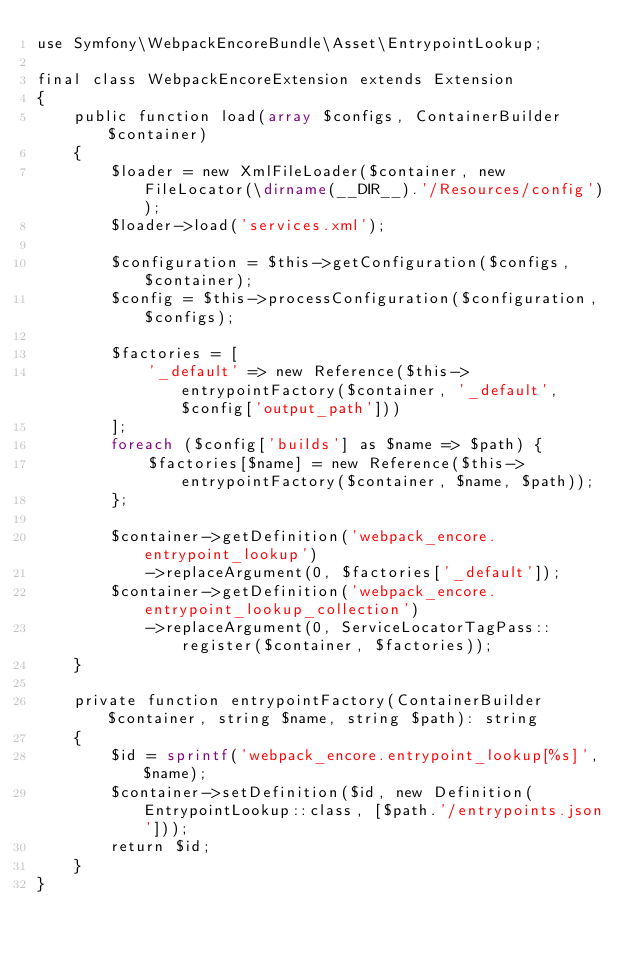<code> <loc_0><loc_0><loc_500><loc_500><_PHP_>use Symfony\WebpackEncoreBundle\Asset\EntrypointLookup;

final class WebpackEncoreExtension extends Extension
{
    public function load(array $configs, ContainerBuilder $container)
    {
        $loader = new XmlFileLoader($container, new FileLocator(\dirname(__DIR__).'/Resources/config'));
        $loader->load('services.xml');

        $configuration = $this->getConfiguration($configs, $container);
        $config = $this->processConfiguration($configuration, $configs);

        $factories = [
            '_default' => new Reference($this->entrypointFactory($container, '_default', $config['output_path']))
        ];
        foreach ($config['builds'] as $name => $path) {
            $factories[$name] = new Reference($this->entrypointFactory($container, $name, $path));
        };

        $container->getDefinition('webpack_encore.entrypoint_lookup')
            ->replaceArgument(0, $factories['_default']);
        $container->getDefinition('webpack_encore.entrypoint_lookup_collection')
            ->replaceArgument(0, ServiceLocatorTagPass::register($container, $factories));
    }

    private function entrypointFactory(ContainerBuilder $container, string $name, string $path): string
    {
        $id = sprintf('webpack_encore.entrypoint_lookup[%s]', $name);
        $container->setDefinition($id, new Definition(EntrypointLookup::class, [$path.'/entrypoints.json']));
        return $id;
    }
}
</code> 